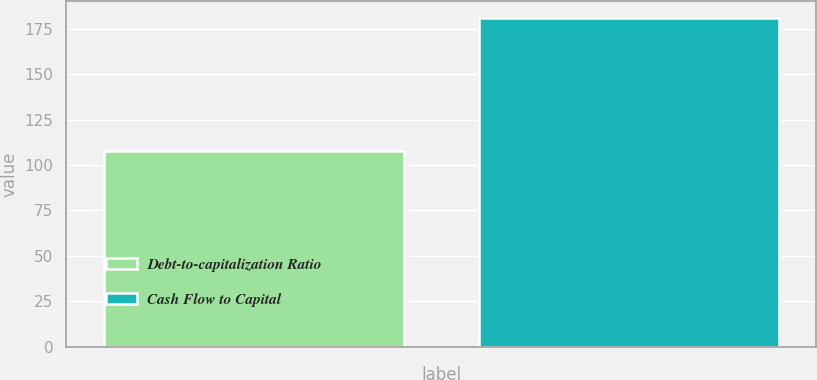Convert chart. <chart><loc_0><loc_0><loc_500><loc_500><bar_chart><fcel>Debt-to-capitalization Ratio<fcel>Cash Flow to Capital<nl><fcel>108<fcel>181<nl></chart> 